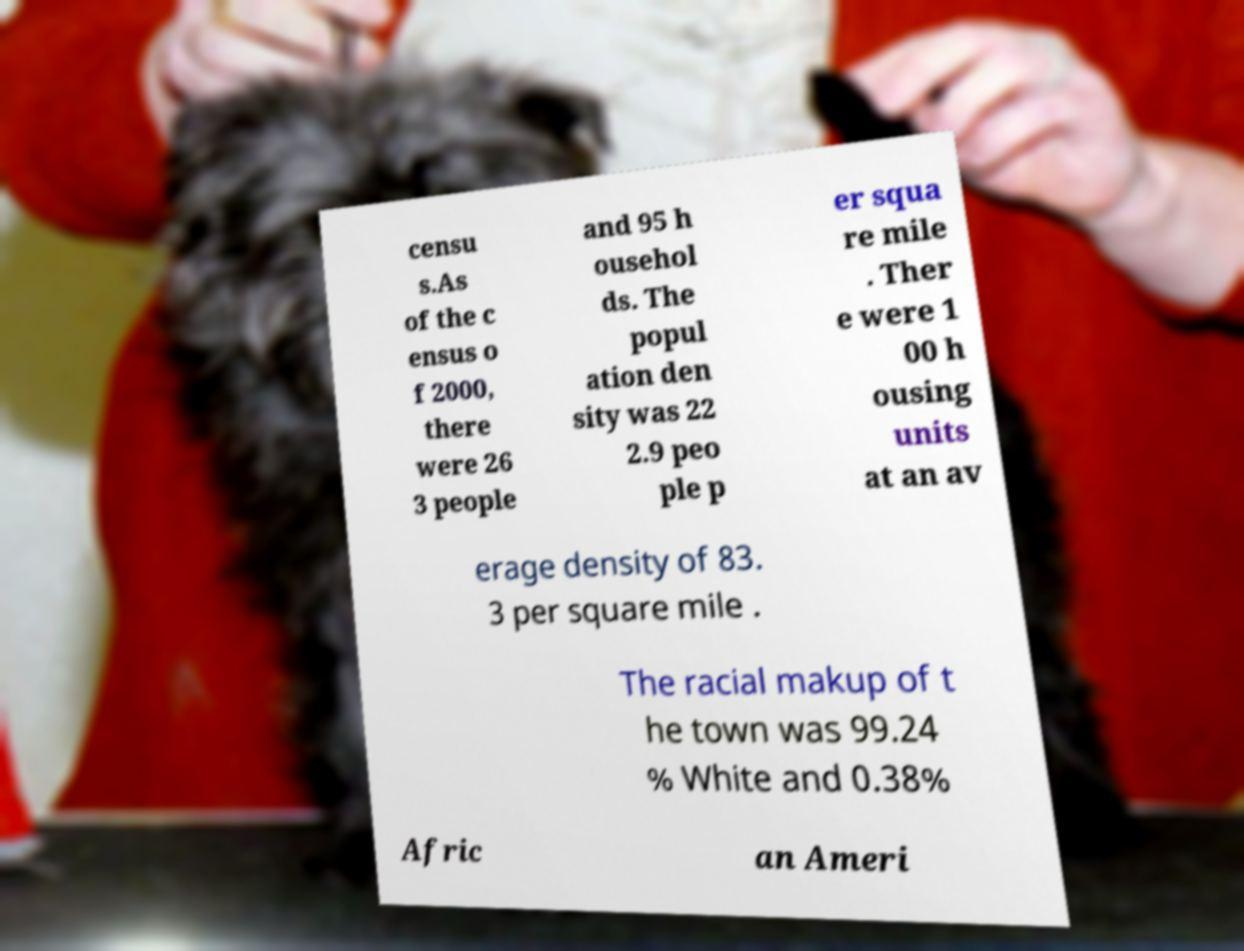Can you read and provide the text displayed in the image?This photo seems to have some interesting text. Can you extract and type it out for me? censu s.As of the c ensus o f 2000, there were 26 3 people and 95 h ousehol ds. The popul ation den sity was 22 2.9 peo ple p er squa re mile . Ther e were 1 00 h ousing units at an av erage density of 83. 3 per square mile . The racial makup of t he town was 99.24 % White and 0.38% Afric an Ameri 